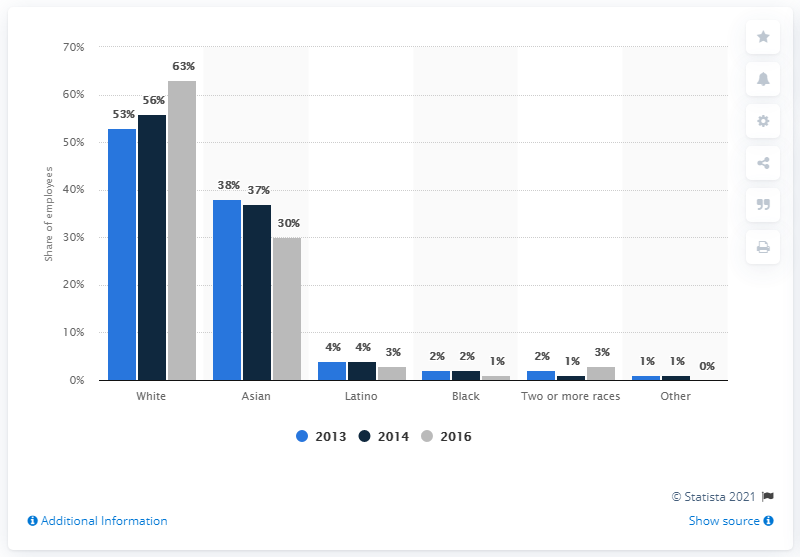Give some essential details in this illustration. According to data from 2016, three percent of U.S. LinkedIn employees identified as Latino. 